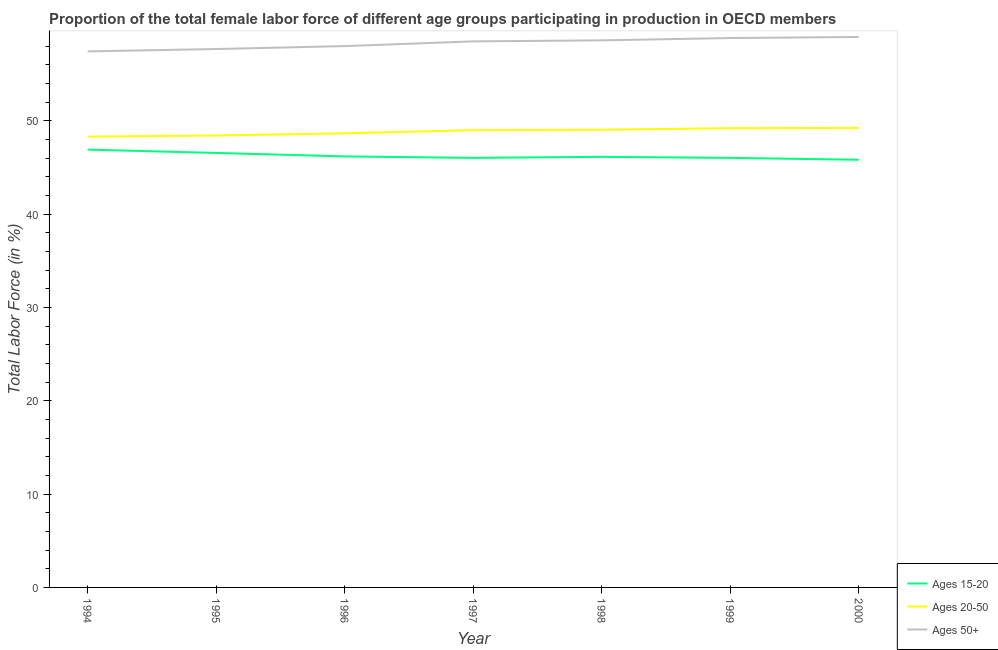How many different coloured lines are there?
Keep it short and to the point. 3. Is the number of lines equal to the number of legend labels?
Give a very brief answer. Yes. What is the percentage of female labor force above age 50 in 1997?
Keep it short and to the point. 58.53. Across all years, what is the maximum percentage of female labor force above age 50?
Your answer should be very brief. 59. Across all years, what is the minimum percentage of female labor force within the age group 20-50?
Give a very brief answer. 48.31. What is the total percentage of female labor force within the age group 15-20 in the graph?
Provide a succinct answer. 323.76. What is the difference between the percentage of female labor force within the age group 20-50 in 1996 and that in 2000?
Offer a terse response. -0.58. What is the difference between the percentage of female labor force within the age group 20-50 in 1997 and the percentage of female labor force within the age group 15-20 in 1996?
Make the answer very short. 2.81. What is the average percentage of female labor force within the age group 20-50 per year?
Provide a short and direct response. 48.85. In the year 2000, what is the difference between the percentage of female labor force above age 50 and percentage of female labor force within the age group 15-20?
Give a very brief answer. 13.16. What is the ratio of the percentage of female labor force within the age group 20-50 in 1998 to that in 2000?
Keep it short and to the point. 1. Is the percentage of female labor force within the age group 15-20 in 1996 less than that in 1999?
Your response must be concise. No. Is the difference between the percentage of female labor force above age 50 in 1995 and 1996 greater than the difference between the percentage of female labor force within the age group 20-50 in 1995 and 1996?
Provide a succinct answer. No. What is the difference between the highest and the second highest percentage of female labor force within the age group 20-50?
Keep it short and to the point. 0.02. What is the difference between the highest and the lowest percentage of female labor force above age 50?
Offer a terse response. 1.54. Is the percentage of female labor force within the age group 20-50 strictly less than the percentage of female labor force within the age group 15-20 over the years?
Provide a short and direct response. No. What is the difference between two consecutive major ticks on the Y-axis?
Your answer should be compact. 10. Does the graph contain any zero values?
Provide a succinct answer. No. Where does the legend appear in the graph?
Offer a terse response. Bottom right. How many legend labels are there?
Make the answer very short. 3. What is the title of the graph?
Offer a very short reply. Proportion of the total female labor force of different age groups participating in production in OECD members. What is the label or title of the X-axis?
Keep it short and to the point. Year. What is the label or title of the Y-axis?
Offer a very short reply. Total Labor Force (in %). What is the Total Labor Force (in %) of Ages 15-20 in 1994?
Your answer should be very brief. 46.92. What is the Total Labor Force (in %) of Ages 20-50 in 1994?
Offer a terse response. 48.31. What is the Total Labor Force (in %) of Ages 50+ in 1994?
Offer a terse response. 57.46. What is the Total Labor Force (in %) of Ages 15-20 in 1995?
Provide a short and direct response. 46.57. What is the Total Labor Force (in %) of Ages 20-50 in 1995?
Make the answer very short. 48.44. What is the Total Labor Force (in %) in Ages 50+ in 1995?
Your answer should be compact. 57.71. What is the Total Labor Force (in %) of Ages 15-20 in 1996?
Your response must be concise. 46.2. What is the Total Labor Force (in %) in Ages 20-50 in 1996?
Ensure brevity in your answer.  48.67. What is the Total Labor Force (in %) in Ages 50+ in 1996?
Offer a very short reply. 58.02. What is the Total Labor Force (in %) of Ages 15-20 in 1997?
Provide a succinct answer. 46.04. What is the Total Labor Force (in %) of Ages 20-50 in 1997?
Your answer should be compact. 49.01. What is the Total Labor Force (in %) in Ages 50+ in 1997?
Provide a short and direct response. 58.53. What is the Total Labor Force (in %) in Ages 15-20 in 1998?
Offer a very short reply. 46.15. What is the Total Labor Force (in %) in Ages 20-50 in 1998?
Your answer should be very brief. 49.05. What is the Total Labor Force (in %) of Ages 50+ in 1998?
Your response must be concise. 58.64. What is the Total Labor Force (in %) in Ages 15-20 in 1999?
Give a very brief answer. 46.04. What is the Total Labor Force (in %) in Ages 20-50 in 1999?
Offer a very short reply. 49.23. What is the Total Labor Force (in %) of Ages 50+ in 1999?
Your response must be concise. 58.89. What is the Total Labor Force (in %) in Ages 15-20 in 2000?
Your answer should be very brief. 45.84. What is the Total Labor Force (in %) in Ages 20-50 in 2000?
Make the answer very short. 49.25. What is the Total Labor Force (in %) of Ages 50+ in 2000?
Give a very brief answer. 59. Across all years, what is the maximum Total Labor Force (in %) in Ages 15-20?
Give a very brief answer. 46.92. Across all years, what is the maximum Total Labor Force (in %) in Ages 20-50?
Ensure brevity in your answer.  49.25. Across all years, what is the maximum Total Labor Force (in %) in Ages 50+?
Offer a very short reply. 59. Across all years, what is the minimum Total Labor Force (in %) of Ages 15-20?
Provide a succinct answer. 45.84. Across all years, what is the minimum Total Labor Force (in %) of Ages 20-50?
Your answer should be very brief. 48.31. Across all years, what is the minimum Total Labor Force (in %) of Ages 50+?
Make the answer very short. 57.46. What is the total Total Labor Force (in %) of Ages 15-20 in the graph?
Give a very brief answer. 323.76. What is the total Total Labor Force (in %) in Ages 20-50 in the graph?
Offer a terse response. 341.97. What is the total Total Labor Force (in %) of Ages 50+ in the graph?
Provide a succinct answer. 408.23. What is the difference between the Total Labor Force (in %) in Ages 15-20 in 1994 and that in 1995?
Offer a very short reply. 0.36. What is the difference between the Total Labor Force (in %) in Ages 20-50 in 1994 and that in 1995?
Your answer should be compact. -0.13. What is the difference between the Total Labor Force (in %) of Ages 50+ in 1994 and that in 1995?
Make the answer very short. -0.25. What is the difference between the Total Labor Force (in %) of Ages 15-20 in 1994 and that in 1996?
Offer a very short reply. 0.73. What is the difference between the Total Labor Force (in %) of Ages 20-50 in 1994 and that in 1996?
Provide a succinct answer. -0.36. What is the difference between the Total Labor Force (in %) of Ages 50+ in 1994 and that in 1996?
Your answer should be very brief. -0.57. What is the difference between the Total Labor Force (in %) in Ages 15-20 in 1994 and that in 1997?
Ensure brevity in your answer.  0.88. What is the difference between the Total Labor Force (in %) of Ages 20-50 in 1994 and that in 1997?
Provide a succinct answer. -0.7. What is the difference between the Total Labor Force (in %) in Ages 50+ in 1994 and that in 1997?
Your answer should be very brief. -1.07. What is the difference between the Total Labor Force (in %) in Ages 15-20 in 1994 and that in 1998?
Your answer should be compact. 0.77. What is the difference between the Total Labor Force (in %) of Ages 20-50 in 1994 and that in 1998?
Your answer should be compact. -0.74. What is the difference between the Total Labor Force (in %) of Ages 50+ in 1994 and that in 1998?
Ensure brevity in your answer.  -1.18. What is the difference between the Total Labor Force (in %) in Ages 15-20 in 1994 and that in 1999?
Your response must be concise. 0.88. What is the difference between the Total Labor Force (in %) in Ages 20-50 in 1994 and that in 1999?
Ensure brevity in your answer.  -0.91. What is the difference between the Total Labor Force (in %) of Ages 50+ in 1994 and that in 1999?
Offer a terse response. -1.43. What is the difference between the Total Labor Force (in %) in Ages 15-20 in 1994 and that in 2000?
Ensure brevity in your answer.  1.09. What is the difference between the Total Labor Force (in %) in Ages 20-50 in 1994 and that in 2000?
Provide a short and direct response. -0.93. What is the difference between the Total Labor Force (in %) in Ages 50+ in 1994 and that in 2000?
Offer a very short reply. -1.54. What is the difference between the Total Labor Force (in %) in Ages 15-20 in 1995 and that in 1996?
Provide a succinct answer. 0.37. What is the difference between the Total Labor Force (in %) in Ages 20-50 in 1995 and that in 1996?
Offer a terse response. -0.23. What is the difference between the Total Labor Force (in %) of Ages 50+ in 1995 and that in 1996?
Ensure brevity in your answer.  -0.31. What is the difference between the Total Labor Force (in %) in Ages 15-20 in 1995 and that in 1997?
Give a very brief answer. 0.53. What is the difference between the Total Labor Force (in %) in Ages 20-50 in 1995 and that in 1997?
Offer a terse response. -0.57. What is the difference between the Total Labor Force (in %) of Ages 50+ in 1995 and that in 1997?
Give a very brief answer. -0.82. What is the difference between the Total Labor Force (in %) of Ages 15-20 in 1995 and that in 1998?
Your answer should be compact. 0.42. What is the difference between the Total Labor Force (in %) in Ages 20-50 in 1995 and that in 1998?
Make the answer very short. -0.61. What is the difference between the Total Labor Force (in %) in Ages 50+ in 1995 and that in 1998?
Ensure brevity in your answer.  -0.93. What is the difference between the Total Labor Force (in %) of Ages 15-20 in 1995 and that in 1999?
Your answer should be very brief. 0.53. What is the difference between the Total Labor Force (in %) in Ages 20-50 in 1995 and that in 1999?
Your response must be concise. -0.79. What is the difference between the Total Labor Force (in %) of Ages 50+ in 1995 and that in 1999?
Your response must be concise. -1.18. What is the difference between the Total Labor Force (in %) of Ages 15-20 in 1995 and that in 2000?
Your answer should be compact. 0.73. What is the difference between the Total Labor Force (in %) in Ages 20-50 in 1995 and that in 2000?
Provide a succinct answer. -0.81. What is the difference between the Total Labor Force (in %) of Ages 50+ in 1995 and that in 2000?
Make the answer very short. -1.29. What is the difference between the Total Labor Force (in %) in Ages 15-20 in 1996 and that in 1997?
Your answer should be very brief. 0.16. What is the difference between the Total Labor Force (in %) in Ages 20-50 in 1996 and that in 1997?
Provide a succinct answer. -0.34. What is the difference between the Total Labor Force (in %) in Ages 50+ in 1996 and that in 1997?
Offer a very short reply. -0.51. What is the difference between the Total Labor Force (in %) of Ages 15-20 in 1996 and that in 1998?
Make the answer very short. 0.05. What is the difference between the Total Labor Force (in %) of Ages 20-50 in 1996 and that in 1998?
Offer a very short reply. -0.38. What is the difference between the Total Labor Force (in %) in Ages 50+ in 1996 and that in 1998?
Give a very brief answer. -0.61. What is the difference between the Total Labor Force (in %) in Ages 15-20 in 1996 and that in 1999?
Your response must be concise. 0.16. What is the difference between the Total Labor Force (in %) in Ages 20-50 in 1996 and that in 1999?
Provide a succinct answer. -0.55. What is the difference between the Total Labor Force (in %) of Ages 50+ in 1996 and that in 1999?
Your response must be concise. -0.86. What is the difference between the Total Labor Force (in %) of Ages 15-20 in 1996 and that in 2000?
Offer a terse response. 0.36. What is the difference between the Total Labor Force (in %) in Ages 20-50 in 1996 and that in 2000?
Ensure brevity in your answer.  -0.58. What is the difference between the Total Labor Force (in %) of Ages 50+ in 1996 and that in 2000?
Give a very brief answer. -0.98. What is the difference between the Total Labor Force (in %) in Ages 15-20 in 1997 and that in 1998?
Give a very brief answer. -0.11. What is the difference between the Total Labor Force (in %) in Ages 20-50 in 1997 and that in 1998?
Offer a terse response. -0.04. What is the difference between the Total Labor Force (in %) in Ages 50+ in 1997 and that in 1998?
Offer a very short reply. -0.11. What is the difference between the Total Labor Force (in %) of Ages 15-20 in 1997 and that in 1999?
Offer a very short reply. -0. What is the difference between the Total Labor Force (in %) of Ages 20-50 in 1997 and that in 1999?
Provide a succinct answer. -0.21. What is the difference between the Total Labor Force (in %) of Ages 50+ in 1997 and that in 1999?
Keep it short and to the point. -0.36. What is the difference between the Total Labor Force (in %) in Ages 15-20 in 1997 and that in 2000?
Your response must be concise. 0.2. What is the difference between the Total Labor Force (in %) of Ages 20-50 in 1997 and that in 2000?
Ensure brevity in your answer.  -0.24. What is the difference between the Total Labor Force (in %) of Ages 50+ in 1997 and that in 2000?
Your response must be concise. -0.47. What is the difference between the Total Labor Force (in %) in Ages 15-20 in 1998 and that in 1999?
Keep it short and to the point. 0.11. What is the difference between the Total Labor Force (in %) in Ages 20-50 in 1998 and that in 1999?
Provide a short and direct response. -0.17. What is the difference between the Total Labor Force (in %) of Ages 50+ in 1998 and that in 1999?
Your answer should be compact. -0.25. What is the difference between the Total Labor Force (in %) of Ages 15-20 in 1998 and that in 2000?
Provide a succinct answer. 0.32. What is the difference between the Total Labor Force (in %) in Ages 20-50 in 1998 and that in 2000?
Give a very brief answer. -0.2. What is the difference between the Total Labor Force (in %) in Ages 50+ in 1998 and that in 2000?
Keep it short and to the point. -0.36. What is the difference between the Total Labor Force (in %) of Ages 15-20 in 1999 and that in 2000?
Provide a short and direct response. 0.2. What is the difference between the Total Labor Force (in %) in Ages 20-50 in 1999 and that in 2000?
Give a very brief answer. -0.02. What is the difference between the Total Labor Force (in %) in Ages 50+ in 1999 and that in 2000?
Your response must be concise. -0.11. What is the difference between the Total Labor Force (in %) in Ages 15-20 in 1994 and the Total Labor Force (in %) in Ages 20-50 in 1995?
Keep it short and to the point. -1.52. What is the difference between the Total Labor Force (in %) in Ages 15-20 in 1994 and the Total Labor Force (in %) in Ages 50+ in 1995?
Your answer should be very brief. -10.78. What is the difference between the Total Labor Force (in %) in Ages 20-50 in 1994 and the Total Labor Force (in %) in Ages 50+ in 1995?
Your response must be concise. -9.39. What is the difference between the Total Labor Force (in %) of Ages 15-20 in 1994 and the Total Labor Force (in %) of Ages 20-50 in 1996?
Your answer should be very brief. -1.75. What is the difference between the Total Labor Force (in %) in Ages 15-20 in 1994 and the Total Labor Force (in %) in Ages 50+ in 1996?
Your response must be concise. -11.1. What is the difference between the Total Labor Force (in %) in Ages 20-50 in 1994 and the Total Labor Force (in %) in Ages 50+ in 1996?
Offer a very short reply. -9.71. What is the difference between the Total Labor Force (in %) of Ages 15-20 in 1994 and the Total Labor Force (in %) of Ages 20-50 in 1997?
Your answer should be very brief. -2.09. What is the difference between the Total Labor Force (in %) in Ages 15-20 in 1994 and the Total Labor Force (in %) in Ages 50+ in 1997?
Offer a terse response. -11.6. What is the difference between the Total Labor Force (in %) of Ages 20-50 in 1994 and the Total Labor Force (in %) of Ages 50+ in 1997?
Ensure brevity in your answer.  -10.21. What is the difference between the Total Labor Force (in %) in Ages 15-20 in 1994 and the Total Labor Force (in %) in Ages 20-50 in 1998?
Ensure brevity in your answer.  -2.13. What is the difference between the Total Labor Force (in %) in Ages 15-20 in 1994 and the Total Labor Force (in %) in Ages 50+ in 1998?
Give a very brief answer. -11.71. What is the difference between the Total Labor Force (in %) of Ages 20-50 in 1994 and the Total Labor Force (in %) of Ages 50+ in 1998?
Provide a short and direct response. -10.32. What is the difference between the Total Labor Force (in %) of Ages 15-20 in 1994 and the Total Labor Force (in %) of Ages 20-50 in 1999?
Offer a very short reply. -2.3. What is the difference between the Total Labor Force (in %) in Ages 15-20 in 1994 and the Total Labor Force (in %) in Ages 50+ in 1999?
Your response must be concise. -11.96. What is the difference between the Total Labor Force (in %) in Ages 20-50 in 1994 and the Total Labor Force (in %) in Ages 50+ in 1999?
Provide a short and direct response. -10.57. What is the difference between the Total Labor Force (in %) of Ages 15-20 in 1994 and the Total Labor Force (in %) of Ages 20-50 in 2000?
Your answer should be very brief. -2.32. What is the difference between the Total Labor Force (in %) in Ages 15-20 in 1994 and the Total Labor Force (in %) in Ages 50+ in 2000?
Keep it short and to the point. -12.08. What is the difference between the Total Labor Force (in %) in Ages 20-50 in 1994 and the Total Labor Force (in %) in Ages 50+ in 2000?
Offer a very short reply. -10.69. What is the difference between the Total Labor Force (in %) of Ages 15-20 in 1995 and the Total Labor Force (in %) of Ages 20-50 in 1996?
Your response must be concise. -2.1. What is the difference between the Total Labor Force (in %) of Ages 15-20 in 1995 and the Total Labor Force (in %) of Ages 50+ in 1996?
Your response must be concise. -11.45. What is the difference between the Total Labor Force (in %) of Ages 20-50 in 1995 and the Total Labor Force (in %) of Ages 50+ in 1996?
Make the answer very short. -9.58. What is the difference between the Total Labor Force (in %) in Ages 15-20 in 1995 and the Total Labor Force (in %) in Ages 20-50 in 1997?
Your answer should be compact. -2.44. What is the difference between the Total Labor Force (in %) in Ages 15-20 in 1995 and the Total Labor Force (in %) in Ages 50+ in 1997?
Give a very brief answer. -11.96. What is the difference between the Total Labor Force (in %) of Ages 20-50 in 1995 and the Total Labor Force (in %) of Ages 50+ in 1997?
Keep it short and to the point. -10.09. What is the difference between the Total Labor Force (in %) of Ages 15-20 in 1995 and the Total Labor Force (in %) of Ages 20-50 in 1998?
Your answer should be very brief. -2.48. What is the difference between the Total Labor Force (in %) of Ages 15-20 in 1995 and the Total Labor Force (in %) of Ages 50+ in 1998?
Give a very brief answer. -12.07. What is the difference between the Total Labor Force (in %) of Ages 20-50 in 1995 and the Total Labor Force (in %) of Ages 50+ in 1998?
Your answer should be very brief. -10.19. What is the difference between the Total Labor Force (in %) of Ages 15-20 in 1995 and the Total Labor Force (in %) of Ages 20-50 in 1999?
Offer a terse response. -2.66. What is the difference between the Total Labor Force (in %) of Ages 15-20 in 1995 and the Total Labor Force (in %) of Ages 50+ in 1999?
Give a very brief answer. -12.32. What is the difference between the Total Labor Force (in %) in Ages 20-50 in 1995 and the Total Labor Force (in %) in Ages 50+ in 1999?
Keep it short and to the point. -10.45. What is the difference between the Total Labor Force (in %) of Ages 15-20 in 1995 and the Total Labor Force (in %) of Ages 20-50 in 2000?
Provide a short and direct response. -2.68. What is the difference between the Total Labor Force (in %) in Ages 15-20 in 1995 and the Total Labor Force (in %) in Ages 50+ in 2000?
Provide a succinct answer. -12.43. What is the difference between the Total Labor Force (in %) of Ages 20-50 in 1995 and the Total Labor Force (in %) of Ages 50+ in 2000?
Your response must be concise. -10.56. What is the difference between the Total Labor Force (in %) of Ages 15-20 in 1996 and the Total Labor Force (in %) of Ages 20-50 in 1997?
Offer a very short reply. -2.81. What is the difference between the Total Labor Force (in %) in Ages 15-20 in 1996 and the Total Labor Force (in %) in Ages 50+ in 1997?
Provide a succinct answer. -12.33. What is the difference between the Total Labor Force (in %) of Ages 20-50 in 1996 and the Total Labor Force (in %) of Ages 50+ in 1997?
Your answer should be very brief. -9.85. What is the difference between the Total Labor Force (in %) of Ages 15-20 in 1996 and the Total Labor Force (in %) of Ages 20-50 in 1998?
Offer a very short reply. -2.85. What is the difference between the Total Labor Force (in %) in Ages 15-20 in 1996 and the Total Labor Force (in %) in Ages 50+ in 1998?
Ensure brevity in your answer.  -12.44. What is the difference between the Total Labor Force (in %) in Ages 20-50 in 1996 and the Total Labor Force (in %) in Ages 50+ in 1998?
Give a very brief answer. -9.96. What is the difference between the Total Labor Force (in %) in Ages 15-20 in 1996 and the Total Labor Force (in %) in Ages 20-50 in 1999?
Give a very brief answer. -3.03. What is the difference between the Total Labor Force (in %) of Ages 15-20 in 1996 and the Total Labor Force (in %) of Ages 50+ in 1999?
Ensure brevity in your answer.  -12.69. What is the difference between the Total Labor Force (in %) of Ages 20-50 in 1996 and the Total Labor Force (in %) of Ages 50+ in 1999?
Make the answer very short. -10.21. What is the difference between the Total Labor Force (in %) of Ages 15-20 in 1996 and the Total Labor Force (in %) of Ages 20-50 in 2000?
Offer a very short reply. -3.05. What is the difference between the Total Labor Force (in %) of Ages 15-20 in 1996 and the Total Labor Force (in %) of Ages 50+ in 2000?
Offer a very short reply. -12.8. What is the difference between the Total Labor Force (in %) of Ages 20-50 in 1996 and the Total Labor Force (in %) of Ages 50+ in 2000?
Your answer should be very brief. -10.33. What is the difference between the Total Labor Force (in %) of Ages 15-20 in 1997 and the Total Labor Force (in %) of Ages 20-50 in 1998?
Your answer should be compact. -3.01. What is the difference between the Total Labor Force (in %) in Ages 15-20 in 1997 and the Total Labor Force (in %) in Ages 50+ in 1998?
Provide a short and direct response. -12.59. What is the difference between the Total Labor Force (in %) in Ages 20-50 in 1997 and the Total Labor Force (in %) in Ages 50+ in 1998?
Make the answer very short. -9.62. What is the difference between the Total Labor Force (in %) of Ages 15-20 in 1997 and the Total Labor Force (in %) of Ages 20-50 in 1999?
Your answer should be compact. -3.19. What is the difference between the Total Labor Force (in %) of Ages 15-20 in 1997 and the Total Labor Force (in %) of Ages 50+ in 1999?
Make the answer very short. -12.85. What is the difference between the Total Labor Force (in %) of Ages 20-50 in 1997 and the Total Labor Force (in %) of Ages 50+ in 1999?
Ensure brevity in your answer.  -9.87. What is the difference between the Total Labor Force (in %) of Ages 15-20 in 1997 and the Total Labor Force (in %) of Ages 20-50 in 2000?
Offer a terse response. -3.21. What is the difference between the Total Labor Force (in %) of Ages 15-20 in 1997 and the Total Labor Force (in %) of Ages 50+ in 2000?
Offer a very short reply. -12.96. What is the difference between the Total Labor Force (in %) of Ages 20-50 in 1997 and the Total Labor Force (in %) of Ages 50+ in 2000?
Provide a succinct answer. -9.99. What is the difference between the Total Labor Force (in %) of Ages 15-20 in 1998 and the Total Labor Force (in %) of Ages 20-50 in 1999?
Offer a very short reply. -3.08. What is the difference between the Total Labor Force (in %) in Ages 15-20 in 1998 and the Total Labor Force (in %) in Ages 50+ in 1999?
Give a very brief answer. -12.73. What is the difference between the Total Labor Force (in %) of Ages 20-50 in 1998 and the Total Labor Force (in %) of Ages 50+ in 1999?
Your response must be concise. -9.83. What is the difference between the Total Labor Force (in %) of Ages 15-20 in 1998 and the Total Labor Force (in %) of Ages 20-50 in 2000?
Ensure brevity in your answer.  -3.1. What is the difference between the Total Labor Force (in %) in Ages 15-20 in 1998 and the Total Labor Force (in %) in Ages 50+ in 2000?
Your answer should be compact. -12.85. What is the difference between the Total Labor Force (in %) in Ages 20-50 in 1998 and the Total Labor Force (in %) in Ages 50+ in 2000?
Provide a short and direct response. -9.95. What is the difference between the Total Labor Force (in %) in Ages 15-20 in 1999 and the Total Labor Force (in %) in Ages 20-50 in 2000?
Your response must be concise. -3.21. What is the difference between the Total Labor Force (in %) in Ages 15-20 in 1999 and the Total Labor Force (in %) in Ages 50+ in 2000?
Offer a very short reply. -12.96. What is the difference between the Total Labor Force (in %) in Ages 20-50 in 1999 and the Total Labor Force (in %) in Ages 50+ in 2000?
Keep it short and to the point. -9.77. What is the average Total Labor Force (in %) in Ages 15-20 per year?
Your response must be concise. 46.25. What is the average Total Labor Force (in %) in Ages 20-50 per year?
Keep it short and to the point. 48.85. What is the average Total Labor Force (in %) in Ages 50+ per year?
Provide a short and direct response. 58.32. In the year 1994, what is the difference between the Total Labor Force (in %) in Ages 15-20 and Total Labor Force (in %) in Ages 20-50?
Your response must be concise. -1.39. In the year 1994, what is the difference between the Total Labor Force (in %) in Ages 15-20 and Total Labor Force (in %) in Ages 50+?
Your answer should be compact. -10.53. In the year 1994, what is the difference between the Total Labor Force (in %) in Ages 20-50 and Total Labor Force (in %) in Ages 50+?
Give a very brief answer. -9.14. In the year 1995, what is the difference between the Total Labor Force (in %) in Ages 15-20 and Total Labor Force (in %) in Ages 20-50?
Offer a terse response. -1.87. In the year 1995, what is the difference between the Total Labor Force (in %) in Ages 15-20 and Total Labor Force (in %) in Ages 50+?
Your response must be concise. -11.14. In the year 1995, what is the difference between the Total Labor Force (in %) of Ages 20-50 and Total Labor Force (in %) of Ages 50+?
Your response must be concise. -9.27. In the year 1996, what is the difference between the Total Labor Force (in %) in Ages 15-20 and Total Labor Force (in %) in Ages 20-50?
Provide a short and direct response. -2.47. In the year 1996, what is the difference between the Total Labor Force (in %) of Ages 15-20 and Total Labor Force (in %) of Ages 50+?
Your answer should be compact. -11.82. In the year 1996, what is the difference between the Total Labor Force (in %) in Ages 20-50 and Total Labor Force (in %) in Ages 50+?
Give a very brief answer. -9.35. In the year 1997, what is the difference between the Total Labor Force (in %) in Ages 15-20 and Total Labor Force (in %) in Ages 20-50?
Offer a terse response. -2.97. In the year 1997, what is the difference between the Total Labor Force (in %) of Ages 15-20 and Total Labor Force (in %) of Ages 50+?
Your answer should be very brief. -12.49. In the year 1997, what is the difference between the Total Labor Force (in %) of Ages 20-50 and Total Labor Force (in %) of Ages 50+?
Give a very brief answer. -9.51. In the year 1998, what is the difference between the Total Labor Force (in %) in Ages 15-20 and Total Labor Force (in %) in Ages 20-50?
Offer a terse response. -2.9. In the year 1998, what is the difference between the Total Labor Force (in %) in Ages 15-20 and Total Labor Force (in %) in Ages 50+?
Provide a succinct answer. -12.48. In the year 1998, what is the difference between the Total Labor Force (in %) in Ages 20-50 and Total Labor Force (in %) in Ages 50+?
Offer a very short reply. -9.58. In the year 1999, what is the difference between the Total Labor Force (in %) of Ages 15-20 and Total Labor Force (in %) of Ages 20-50?
Give a very brief answer. -3.19. In the year 1999, what is the difference between the Total Labor Force (in %) of Ages 15-20 and Total Labor Force (in %) of Ages 50+?
Give a very brief answer. -12.84. In the year 1999, what is the difference between the Total Labor Force (in %) in Ages 20-50 and Total Labor Force (in %) in Ages 50+?
Offer a very short reply. -9.66. In the year 2000, what is the difference between the Total Labor Force (in %) in Ages 15-20 and Total Labor Force (in %) in Ages 20-50?
Your response must be concise. -3.41. In the year 2000, what is the difference between the Total Labor Force (in %) of Ages 15-20 and Total Labor Force (in %) of Ages 50+?
Offer a terse response. -13.16. In the year 2000, what is the difference between the Total Labor Force (in %) in Ages 20-50 and Total Labor Force (in %) in Ages 50+?
Offer a very short reply. -9.75. What is the ratio of the Total Labor Force (in %) of Ages 15-20 in 1994 to that in 1995?
Provide a succinct answer. 1.01. What is the ratio of the Total Labor Force (in %) of Ages 15-20 in 1994 to that in 1996?
Your response must be concise. 1.02. What is the ratio of the Total Labor Force (in %) in Ages 20-50 in 1994 to that in 1996?
Make the answer very short. 0.99. What is the ratio of the Total Labor Force (in %) in Ages 50+ in 1994 to that in 1996?
Give a very brief answer. 0.99. What is the ratio of the Total Labor Force (in %) in Ages 15-20 in 1994 to that in 1997?
Your response must be concise. 1.02. What is the ratio of the Total Labor Force (in %) in Ages 20-50 in 1994 to that in 1997?
Keep it short and to the point. 0.99. What is the ratio of the Total Labor Force (in %) in Ages 50+ in 1994 to that in 1997?
Keep it short and to the point. 0.98. What is the ratio of the Total Labor Force (in %) of Ages 15-20 in 1994 to that in 1998?
Your answer should be very brief. 1.02. What is the ratio of the Total Labor Force (in %) in Ages 20-50 in 1994 to that in 1998?
Ensure brevity in your answer.  0.98. What is the ratio of the Total Labor Force (in %) of Ages 50+ in 1994 to that in 1998?
Keep it short and to the point. 0.98. What is the ratio of the Total Labor Force (in %) of Ages 15-20 in 1994 to that in 1999?
Make the answer very short. 1.02. What is the ratio of the Total Labor Force (in %) of Ages 20-50 in 1994 to that in 1999?
Ensure brevity in your answer.  0.98. What is the ratio of the Total Labor Force (in %) in Ages 50+ in 1994 to that in 1999?
Make the answer very short. 0.98. What is the ratio of the Total Labor Force (in %) of Ages 15-20 in 1994 to that in 2000?
Make the answer very short. 1.02. What is the ratio of the Total Labor Force (in %) in Ages 50+ in 1994 to that in 2000?
Offer a terse response. 0.97. What is the ratio of the Total Labor Force (in %) of Ages 15-20 in 1995 to that in 1996?
Make the answer very short. 1.01. What is the ratio of the Total Labor Force (in %) in Ages 20-50 in 1995 to that in 1996?
Keep it short and to the point. 1. What is the ratio of the Total Labor Force (in %) of Ages 15-20 in 1995 to that in 1997?
Ensure brevity in your answer.  1.01. What is the ratio of the Total Labor Force (in %) of Ages 20-50 in 1995 to that in 1997?
Provide a succinct answer. 0.99. What is the ratio of the Total Labor Force (in %) of Ages 50+ in 1995 to that in 1997?
Make the answer very short. 0.99. What is the ratio of the Total Labor Force (in %) in Ages 15-20 in 1995 to that in 1998?
Offer a very short reply. 1.01. What is the ratio of the Total Labor Force (in %) in Ages 20-50 in 1995 to that in 1998?
Your answer should be compact. 0.99. What is the ratio of the Total Labor Force (in %) of Ages 50+ in 1995 to that in 1998?
Provide a short and direct response. 0.98. What is the ratio of the Total Labor Force (in %) in Ages 15-20 in 1995 to that in 1999?
Your answer should be compact. 1.01. What is the ratio of the Total Labor Force (in %) of Ages 20-50 in 1995 to that in 1999?
Your response must be concise. 0.98. What is the ratio of the Total Labor Force (in %) of Ages 20-50 in 1995 to that in 2000?
Provide a succinct answer. 0.98. What is the ratio of the Total Labor Force (in %) of Ages 50+ in 1995 to that in 2000?
Your answer should be compact. 0.98. What is the ratio of the Total Labor Force (in %) in Ages 15-20 in 1996 to that in 1997?
Make the answer very short. 1. What is the ratio of the Total Labor Force (in %) of Ages 20-50 in 1996 to that in 1997?
Provide a short and direct response. 0.99. What is the ratio of the Total Labor Force (in %) in Ages 20-50 in 1996 to that in 1998?
Offer a very short reply. 0.99. What is the ratio of the Total Labor Force (in %) of Ages 15-20 in 1996 to that in 1999?
Provide a short and direct response. 1. What is the ratio of the Total Labor Force (in %) of Ages 20-50 in 1996 to that in 1999?
Your answer should be very brief. 0.99. What is the ratio of the Total Labor Force (in %) of Ages 50+ in 1996 to that in 1999?
Your answer should be compact. 0.99. What is the ratio of the Total Labor Force (in %) in Ages 15-20 in 1996 to that in 2000?
Provide a succinct answer. 1.01. What is the ratio of the Total Labor Force (in %) of Ages 20-50 in 1996 to that in 2000?
Keep it short and to the point. 0.99. What is the ratio of the Total Labor Force (in %) in Ages 50+ in 1996 to that in 2000?
Provide a succinct answer. 0.98. What is the ratio of the Total Labor Force (in %) in Ages 50+ in 1997 to that in 1999?
Your answer should be compact. 0.99. What is the ratio of the Total Labor Force (in %) of Ages 15-20 in 1998 to that in 2000?
Make the answer very short. 1.01. What is the ratio of the Total Labor Force (in %) in Ages 50+ in 1998 to that in 2000?
Offer a very short reply. 0.99. What is the ratio of the Total Labor Force (in %) of Ages 15-20 in 1999 to that in 2000?
Keep it short and to the point. 1. What is the difference between the highest and the second highest Total Labor Force (in %) in Ages 15-20?
Make the answer very short. 0.36. What is the difference between the highest and the second highest Total Labor Force (in %) of Ages 20-50?
Provide a short and direct response. 0.02. What is the difference between the highest and the second highest Total Labor Force (in %) of Ages 50+?
Offer a terse response. 0.11. What is the difference between the highest and the lowest Total Labor Force (in %) of Ages 15-20?
Your answer should be compact. 1.09. What is the difference between the highest and the lowest Total Labor Force (in %) of Ages 20-50?
Offer a very short reply. 0.93. What is the difference between the highest and the lowest Total Labor Force (in %) of Ages 50+?
Provide a succinct answer. 1.54. 